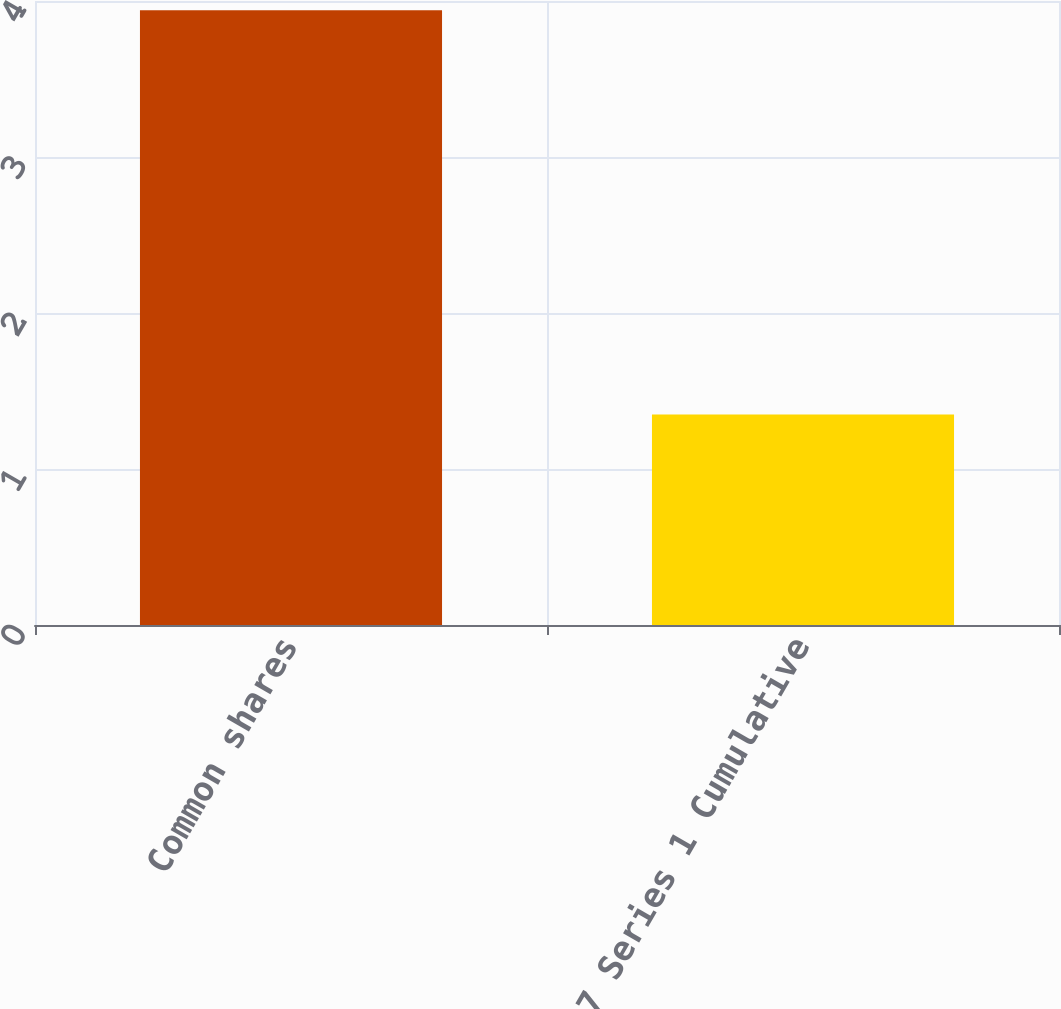Convert chart to OTSL. <chart><loc_0><loc_0><loc_500><loc_500><bar_chart><fcel>Common shares<fcel>5417 Series 1 Cumulative<nl><fcel>3.94<fcel>1.35<nl></chart> 